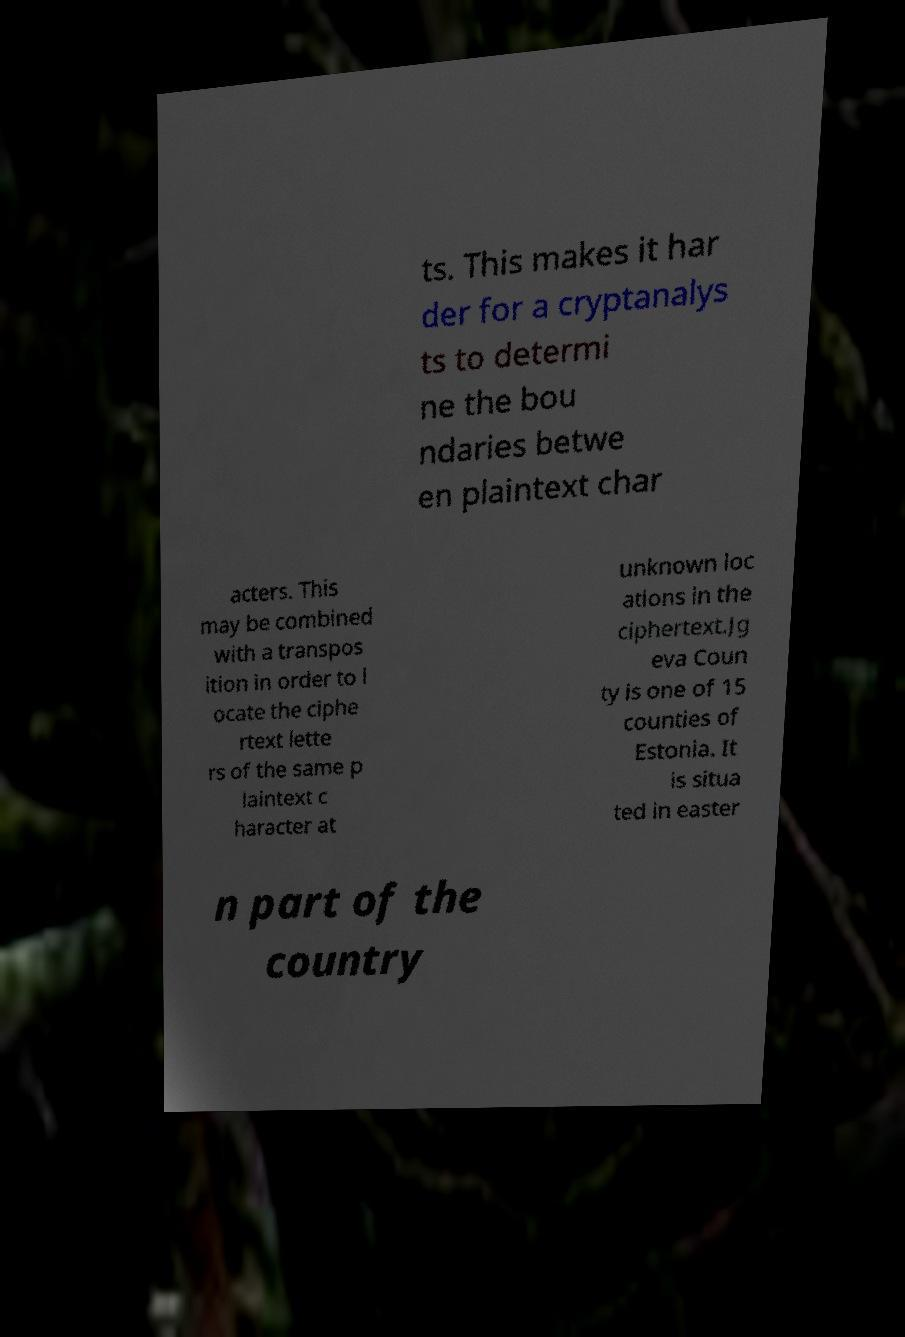Could you extract and type out the text from this image? ts. This makes it har der for a cryptanalys ts to determi ne the bou ndaries betwe en plaintext char acters. This may be combined with a transpos ition in order to l ocate the ciphe rtext lette rs of the same p laintext c haracter at unknown loc ations in the ciphertext.Jg eva Coun ty is one of 15 counties of Estonia. It is situa ted in easter n part of the country 